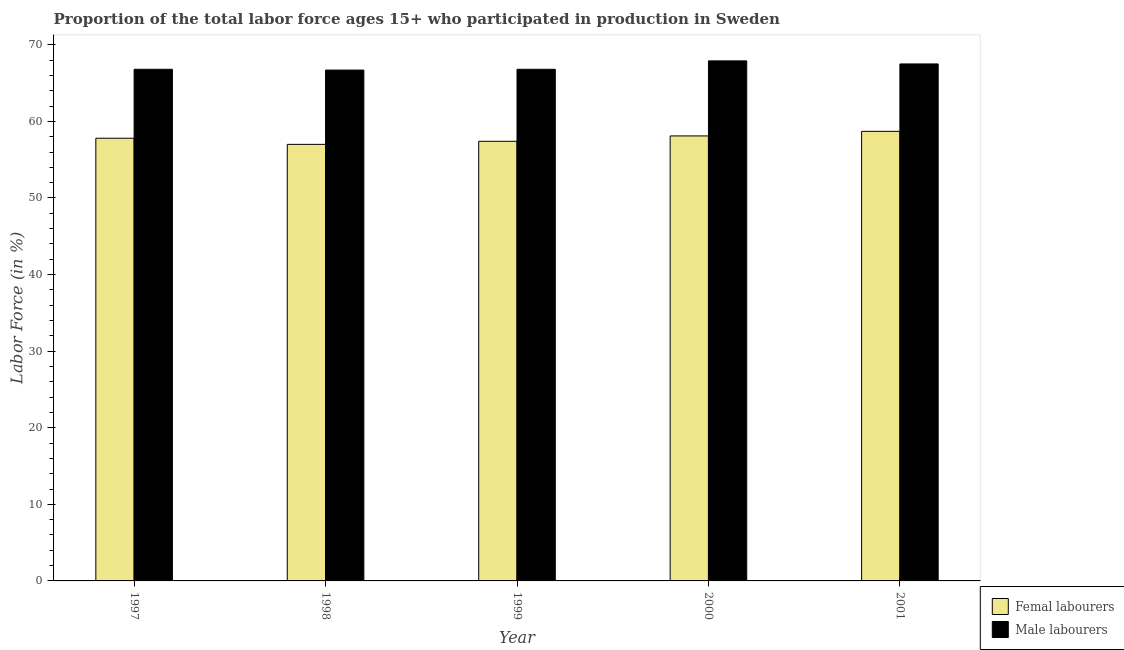How many different coloured bars are there?
Keep it short and to the point. 2. Are the number of bars on each tick of the X-axis equal?
Ensure brevity in your answer.  Yes. How many bars are there on the 3rd tick from the left?
Provide a succinct answer. 2. How many bars are there on the 4th tick from the right?
Provide a short and direct response. 2. What is the label of the 4th group of bars from the left?
Give a very brief answer. 2000. In how many cases, is the number of bars for a given year not equal to the number of legend labels?
Provide a short and direct response. 0. What is the percentage of male labour force in 2000?
Keep it short and to the point. 67.9. Across all years, what is the maximum percentage of female labor force?
Ensure brevity in your answer.  58.7. Across all years, what is the minimum percentage of female labor force?
Offer a very short reply. 57. In which year was the percentage of female labor force maximum?
Keep it short and to the point. 2001. In which year was the percentage of male labour force minimum?
Your answer should be very brief. 1998. What is the total percentage of male labour force in the graph?
Give a very brief answer. 335.7. What is the difference between the percentage of male labour force in 1999 and that in 2001?
Your response must be concise. -0.7. What is the difference between the percentage of male labour force in 1997 and the percentage of female labor force in 1999?
Keep it short and to the point. 0. What is the average percentage of female labor force per year?
Provide a succinct answer. 57.8. What is the ratio of the percentage of male labour force in 1998 to that in 2001?
Your response must be concise. 0.99. Is the difference between the percentage of female labor force in 1999 and 2000 greater than the difference between the percentage of male labour force in 1999 and 2000?
Your answer should be very brief. No. What is the difference between the highest and the second highest percentage of female labor force?
Give a very brief answer. 0.6. What is the difference between the highest and the lowest percentage of female labor force?
Your answer should be very brief. 1.7. Is the sum of the percentage of male labour force in 1998 and 2001 greater than the maximum percentage of female labor force across all years?
Your response must be concise. Yes. What does the 1st bar from the left in 2001 represents?
Provide a succinct answer. Femal labourers. What does the 1st bar from the right in 1998 represents?
Your answer should be compact. Male labourers. What is the difference between two consecutive major ticks on the Y-axis?
Your answer should be compact. 10. Does the graph contain any zero values?
Your response must be concise. No. Does the graph contain grids?
Offer a terse response. No. Where does the legend appear in the graph?
Provide a succinct answer. Bottom right. How many legend labels are there?
Your answer should be very brief. 2. What is the title of the graph?
Give a very brief answer. Proportion of the total labor force ages 15+ who participated in production in Sweden. What is the label or title of the X-axis?
Your answer should be very brief. Year. What is the label or title of the Y-axis?
Ensure brevity in your answer.  Labor Force (in %). What is the Labor Force (in %) of Femal labourers in 1997?
Offer a terse response. 57.8. What is the Labor Force (in %) of Male labourers in 1997?
Your answer should be compact. 66.8. What is the Labor Force (in %) in Femal labourers in 1998?
Provide a succinct answer. 57. What is the Labor Force (in %) of Male labourers in 1998?
Give a very brief answer. 66.7. What is the Labor Force (in %) of Femal labourers in 1999?
Provide a short and direct response. 57.4. What is the Labor Force (in %) of Male labourers in 1999?
Ensure brevity in your answer.  66.8. What is the Labor Force (in %) in Femal labourers in 2000?
Your answer should be compact. 58.1. What is the Labor Force (in %) of Male labourers in 2000?
Give a very brief answer. 67.9. What is the Labor Force (in %) in Femal labourers in 2001?
Ensure brevity in your answer.  58.7. What is the Labor Force (in %) in Male labourers in 2001?
Make the answer very short. 67.5. Across all years, what is the maximum Labor Force (in %) of Femal labourers?
Your answer should be very brief. 58.7. Across all years, what is the maximum Labor Force (in %) in Male labourers?
Your response must be concise. 67.9. Across all years, what is the minimum Labor Force (in %) in Femal labourers?
Your answer should be compact. 57. Across all years, what is the minimum Labor Force (in %) of Male labourers?
Make the answer very short. 66.7. What is the total Labor Force (in %) in Femal labourers in the graph?
Offer a very short reply. 289. What is the total Labor Force (in %) of Male labourers in the graph?
Provide a short and direct response. 335.7. What is the difference between the Labor Force (in %) of Femal labourers in 1997 and that in 1998?
Keep it short and to the point. 0.8. What is the difference between the Labor Force (in %) of Male labourers in 1997 and that in 1999?
Provide a short and direct response. 0. What is the difference between the Labor Force (in %) of Femal labourers in 1998 and that in 2000?
Provide a short and direct response. -1.1. What is the difference between the Labor Force (in %) of Femal labourers in 1998 and that in 2001?
Provide a short and direct response. -1.7. What is the difference between the Labor Force (in %) of Male labourers in 1998 and that in 2001?
Offer a terse response. -0.8. What is the difference between the Labor Force (in %) of Male labourers in 1999 and that in 2000?
Make the answer very short. -1.1. What is the difference between the Labor Force (in %) in Femal labourers in 1999 and that in 2001?
Keep it short and to the point. -1.3. What is the difference between the Labor Force (in %) in Male labourers in 1999 and that in 2001?
Give a very brief answer. -0.7. What is the difference between the Labor Force (in %) in Femal labourers in 2000 and that in 2001?
Your answer should be very brief. -0.6. What is the difference between the Labor Force (in %) of Femal labourers in 1998 and the Labor Force (in %) of Male labourers in 1999?
Keep it short and to the point. -9.8. What is the difference between the Labor Force (in %) in Femal labourers in 1998 and the Labor Force (in %) in Male labourers in 2000?
Make the answer very short. -10.9. What is the difference between the Labor Force (in %) in Femal labourers in 1999 and the Labor Force (in %) in Male labourers in 2001?
Your response must be concise. -10.1. What is the difference between the Labor Force (in %) of Femal labourers in 2000 and the Labor Force (in %) of Male labourers in 2001?
Your response must be concise. -9.4. What is the average Labor Force (in %) in Femal labourers per year?
Your response must be concise. 57.8. What is the average Labor Force (in %) of Male labourers per year?
Provide a succinct answer. 67.14. In the year 1998, what is the difference between the Labor Force (in %) in Femal labourers and Labor Force (in %) in Male labourers?
Provide a short and direct response. -9.7. In the year 2000, what is the difference between the Labor Force (in %) in Femal labourers and Labor Force (in %) in Male labourers?
Provide a short and direct response. -9.8. In the year 2001, what is the difference between the Labor Force (in %) of Femal labourers and Labor Force (in %) of Male labourers?
Make the answer very short. -8.8. What is the ratio of the Labor Force (in %) in Femal labourers in 1997 to that in 1998?
Make the answer very short. 1.01. What is the ratio of the Labor Force (in %) of Male labourers in 1997 to that in 1999?
Offer a terse response. 1. What is the ratio of the Labor Force (in %) of Male labourers in 1997 to that in 2000?
Provide a short and direct response. 0.98. What is the ratio of the Labor Force (in %) of Femal labourers in 1997 to that in 2001?
Your answer should be very brief. 0.98. What is the ratio of the Labor Force (in %) in Femal labourers in 1998 to that in 1999?
Your answer should be compact. 0.99. What is the ratio of the Labor Force (in %) of Male labourers in 1998 to that in 1999?
Make the answer very short. 1. What is the ratio of the Labor Force (in %) in Femal labourers in 1998 to that in 2000?
Your answer should be compact. 0.98. What is the ratio of the Labor Force (in %) in Male labourers in 1998 to that in 2000?
Provide a short and direct response. 0.98. What is the ratio of the Labor Force (in %) of Male labourers in 1998 to that in 2001?
Your response must be concise. 0.99. What is the ratio of the Labor Force (in %) of Femal labourers in 1999 to that in 2000?
Your response must be concise. 0.99. What is the ratio of the Labor Force (in %) of Male labourers in 1999 to that in 2000?
Give a very brief answer. 0.98. What is the ratio of the Labor Force (in %) of Femal labourers in 1999 to that in 2001?
Your answer should be compact. 0.98. What is the ratio of the Labor Force (in %) of Male labourers in 2000 to that in 2001?
Ensure brevity in your answer.  1.01. What is the difference between the highest and the second highest Labor Force (in %) in Male labourers?
Your response must be concise. 0.4. 